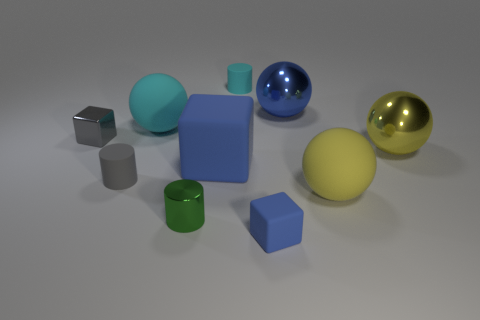Subtract 2 balls. How many balls are left? 2 Subtract all green shiny cylinders. How many cylinders are left? 2 Subtract all spheres. How many objects are left? 6 Subtract all brown spheres. Subtract all brown cubes. How many spheres are left? 4 Subtract all tiny green cylinders. Subtract all gray metal objects. How many objects are left? 8 Add 1 small green cylinders. How many small green cylinders are left? 2 Add 8 tiny green shiny things. How many tiny green shiny things exist? 9 Subtract 0 yellow cubes. How many objects are left? 10 